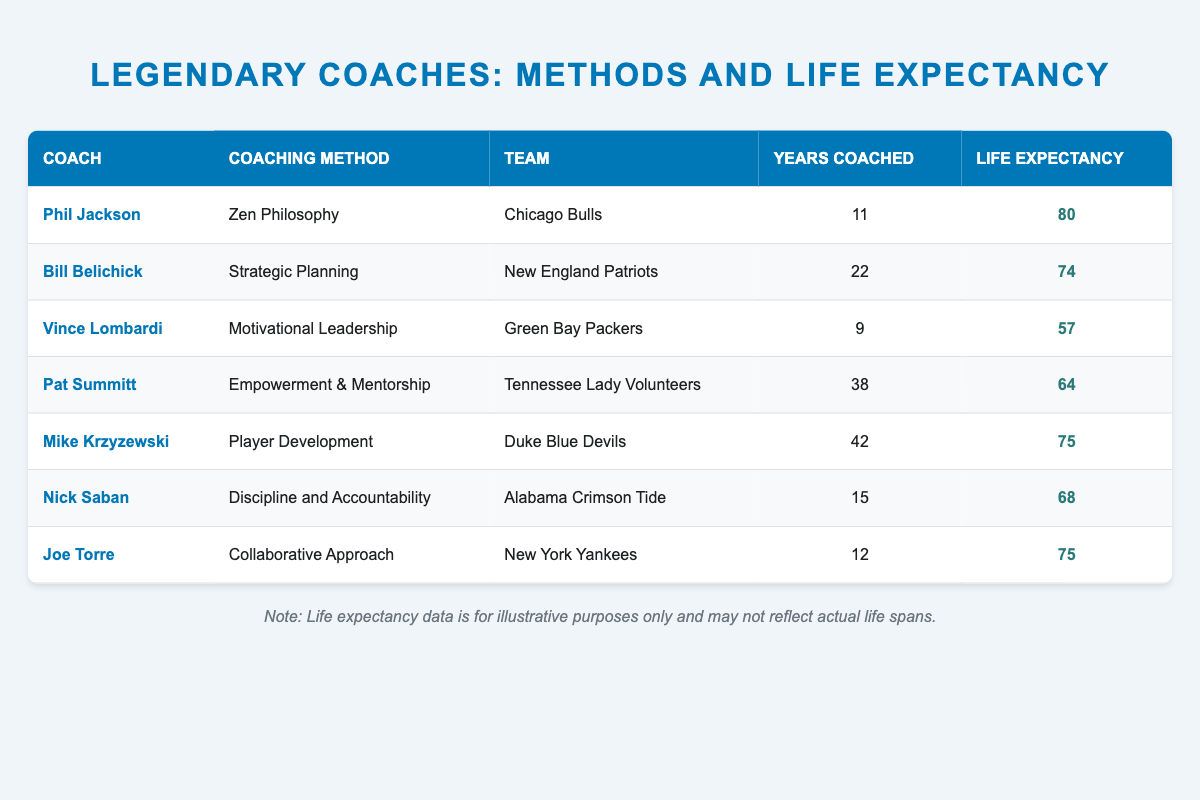What is the life expectancy of Phil Jackson? Phil Jackson's life expectancy is listed in the table as 80.
Answer: 80 What coaching method did Bill Belichick use? Bill Belichick's coaching method is indicated as Strategic Planning in the table.
Answer: Strategic Planning Which coach had the shortest life expectancy? The table shows that Vince Lombardi had the shortest life expectancy at 57.
Answer: 57 What is the average life expectancy of the coaches listed? To find the average, we sum the life expectancies: (80 + 74 + 57 + 64 + 75 + 68 + 75) = 493. There are 7 coaches, so we divide to find the average: 493/7 ≈ 70.43.
Answer: 70.43 Did Joe Torre coach more years than Vince Lombardi? Joe Torre coached for 12 years while Vince Lombardi coached for 9 years, so Joe Torre coached more years.
Answer: Yes What is the difference in life expectancy between Mike Krzyzewski and Nick Saban? Mike Krzyzewski's life expectancy is 75, and Nick Saban's is 68. The difference is calculated as 75 - 68 = 7.
Answer: 7 Based on the data, which coach had the most years of coaching? The table indicates that Pat Summitt coached for 38 years, which is the most among the listed coaches.
Answer: Pat Summitt What percentage of the listed coaches had a life expectancy of over 70? Out of the 7 coaches, 4 had a life expectancy of over 70 (Phil Jackson, Bill Belichick, Mike Krzyzewski, and Joe Torre). The percentage is (4/7) * 100 ≈ 57.14%.
Answer: 57.14% Is it true that all coaches had a life expectancy of at least 60? Checking the table, we see that Vince Lombardi had a life expectancy of 57, which is under 60. Thus, it's false.
Answer: No 